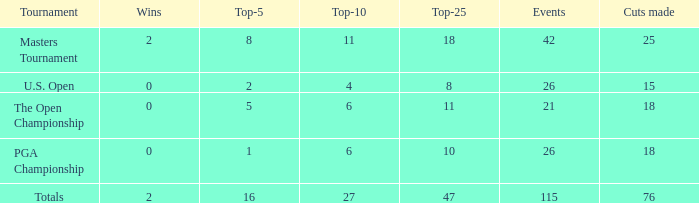Parse the table in full. {'header': ['Tournament', 'Wins', 'Top-5', 'Top-10', 'Top-25', 'Events', 'Cuts made'], 'rows': [['Masters Tournament', '2', '8', '11', '18', '42', '25'], ['U.S. Open', '0', '2', '4', '8', '26', '15'], ['The Open Championship', '0', '5', '6', '11', '21', '18'], ['PGA Championship', '0', '1', '6', '10', '26', '18'], ['Totals', '2', '16', '27', '47', '115', '76']]} What is the total of wins when the cuts made is 76 and the events greater than 115? None. 